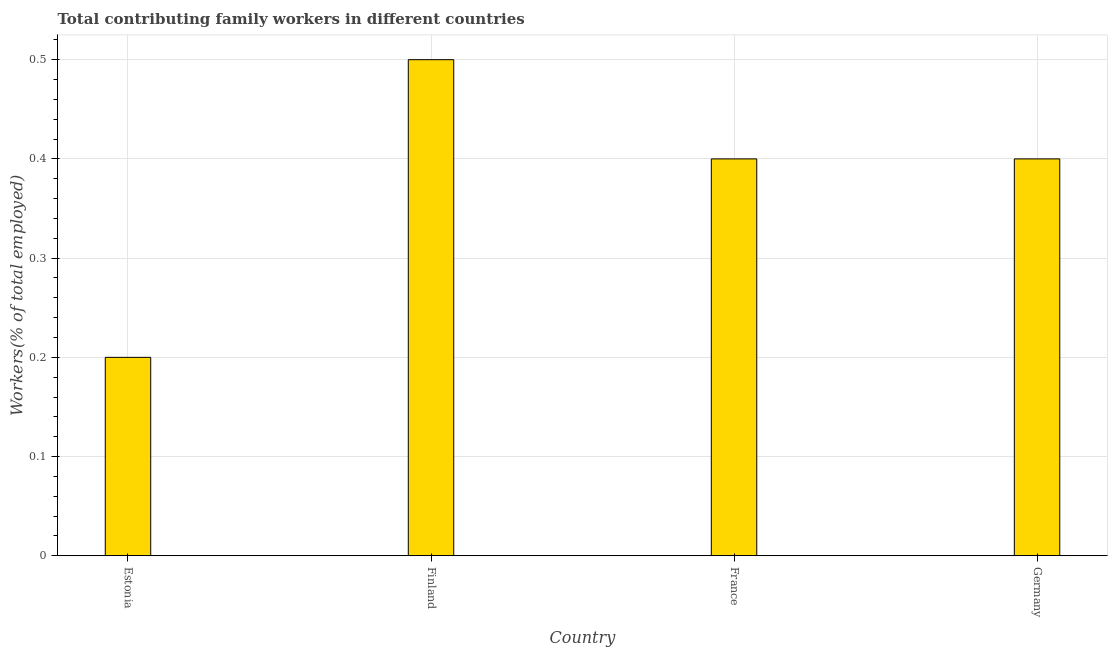Does the graph contain any zero values?
Make the answer very short. No. What is the title of the graph?
Ensure brevity in your answer.  Total contributing family workers in different countries. What is the label or title of the Y-axis?
Ensure brevity in your answer.  Workers(% of total employed). What is the contributing family workers in France?
Keep it short and to the point. 0.4. Across all countries, what is the maximum contributing family workers?
Your answer should be compact. 0.5. Across all countries, what is the minimum contributing family workers?
Offer a terse response. 0.2. In which country was the contributing family workers maximum?
Provide a short and direct response. Finland. In which country was the contributing family workers minimum?
Provide a succinct answer. Estonia. What is the sum of the contributing family workers?
Offer a terse response. 1.5. What is the median contributing family workers?
Offer a very short reply. 0.4. What is the ratio of the contributing family workers in Finland to that in Germany?
Your answer should be compact. 1.25. Is the contributing family workers in Estonia less than that in France?
Offer a terse response. Yes. In how many countries, is the contributing family workers greater than the average contributing family workers taken over all countries?
Your response must be concise. 3. Are all the bars in the graph horizontal?
Your answer should be very brief. No. How many countries are there in the graph?
Offer a terse response. 4. Are the values on the major ticks of Y-axis written in scientific E-notation?
Offer a very short reply. No. What is the Workers(% of total employed) of Estonia?
Keep it short and to the point. 0.2. What is the Workers(% of total employed) of France?
Give a very brief answer. 0.4. What is the Workers(% of total employed) in Germany?
Your answer should be compact. 0.4. What is the difference between the Workers(% of total employed) in Finland and France?
Make the answer very short. 0.1. What is the difference between the Workers(% of total employed) in France and Germany?
Give a very brief answer. 0. What is the ratio of the Workers(% of total employed) in Estonia to that in Finland?
Keep it short and to the point. 0.4. What is the ratio of the Workers(% of total employed) in Estonia to that in France?
Provide a short and direct response. 0.5. What is the ratio of the Workers(% of total employed) in Estonia to that in Germany?
Your answer should be compact. 0.5. What is the ratio of the Workers(% of total employed) in Finland to that in Germany?
Offer a very short reply. 1.25. 